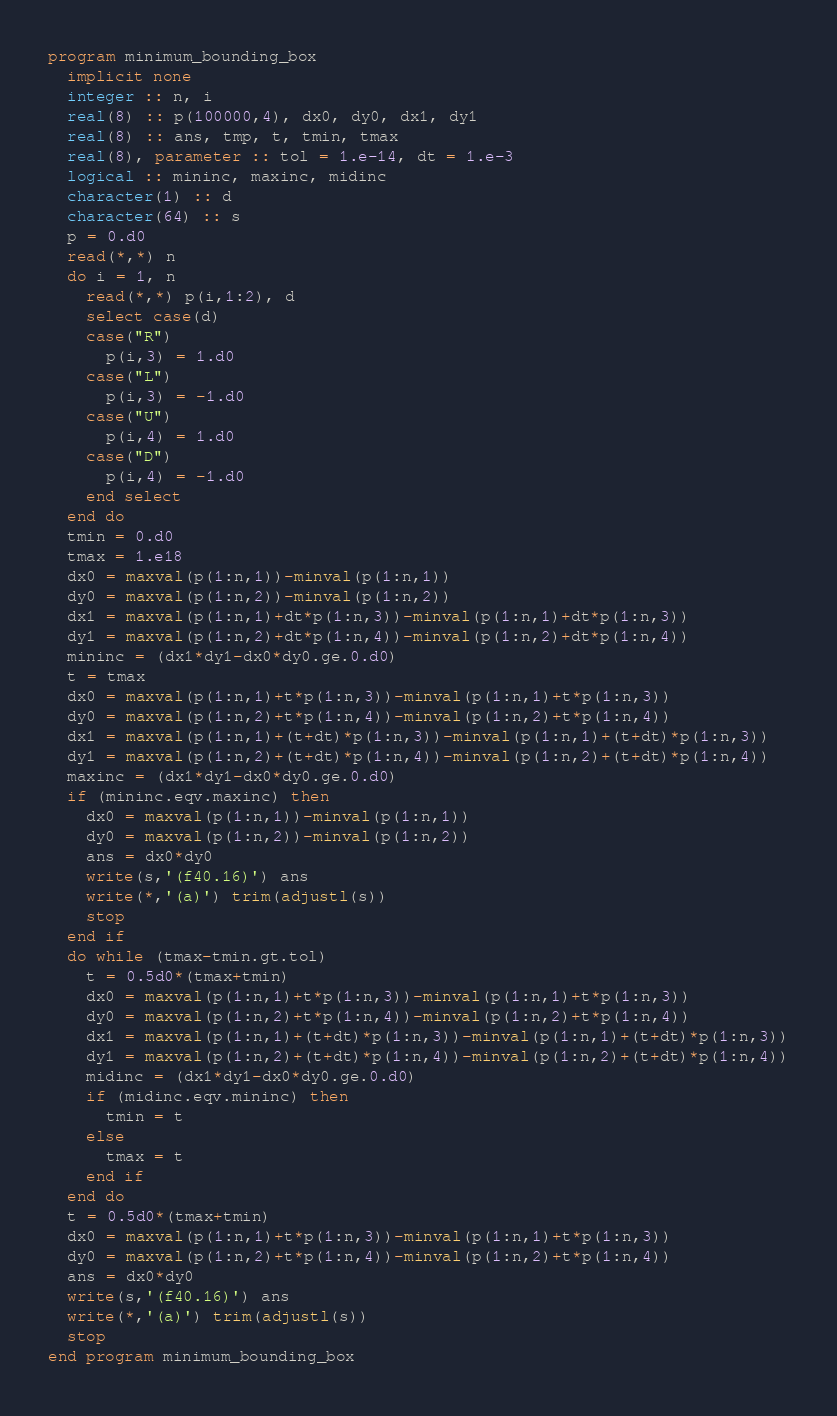<code> <loc_0><loc_0><loc_500><loc_500><_FORTRAN_>program minimum_bounding_box
  implicit none
  integer :: n, i
  real(8) :: p(100000,4), dx0, dy0, dx1, dy1
  real(8) :: ans, tmp, t, tmin, tmax
  real(8), parameter :: tol = 1.e-14, dt = 1.e-3
  logical :: mininc, maxinc, midinc
  character(1) :: d
  character(64) :: s
  p = 0.d0
  read(*,*) n
  do i = 1, n
    read(*,*) p(i,1:2), d
    select case(d)
    case("R")
      p(i,3) = 1.d0
    case("L")
      p(i,3) = -1.d0
    case("U")
      p(i,4) = 1.d0
    case("D")
      p(i,4) = -1.d0
    end select
  end do
  tmin = 0.d0
  tmax = 1.e18
  dx0 = maxval(p(1:n,1))-minval(p(1:n,1))
  dy0 = maxval(p(1:n,2))-minval(p(1:n,2))
  dx1 = maxval(p(1:n,1)+dt*p(1:n,3))-minval(p(1:n,1)+dt*p(1:n,3))
  dy1 = maxval(p(1:n,2)+dt*p(1:n,4))-minval(p(1:n,2)+dt*p(1:n,4))
  mininc = (dx1*dy1-dx0*dy0.ge.0.d0)
  t = tmax
  dx0 = maxval(p(1:n,1)+t*p(1:n,3))-minval(p(1:n,1)+t*p(1:n,3))
  dy0 = maxval(p(1:n,2)+t*p(1:n,4))-minval(p(1:n,2)+t*p(1:n,4))
  dx1 = maxval(p(1:n,1)+(t+dt)*p(1:n,3))-minval(p(1:n,1)+(t+dt)*p(1:n,3))
  dy1 = maxval(p(1:n,2)+(t+dt)*p(1:n,4))-minval(p(1:n,2)+(t+dt)*p(1:n,4))
  maxinc = (dx1*dy1-dx0*dy0.ge.0.d0)
  if (mininc.eqv.maxinc) then
    dx0 = maxval(p(1:n,1))-minval(p(1:n,1))
    dy0 = maxval(p(1:n,2))-minval(p(1:n,2))
    ans = dx0*dy0
    write(s,'(f40.16)') ans
    write(*,'(a)') trim(adjustl(s))
    stop
  end if
  do while (tmax-tmin.gt.tol)
    t = 0.5d0*(tmax+tmin)
    dx0 = maxval(p(1:n,1)+t*p(1:n,3))-minval(p(1:n,1)+t*p(1:n,3))
    dy0 = maxval(p(1:n,2)+t*p(1:n,4))-minval(p(1:n,2)+t*p(1:n,4))
    dx1 = maxval(p(1:n,1)+(t+dt)*p(1:n,3))-minval(p(1:n,1)+(t+dt)*p(1:n,3))
    dy1 = maxval(p(1:n,2)+(t+dt)*p(1:n,4))-minval(p(1:n,2)+(t+dt)*p(1:n,4))
    midinc = (dx1*dy1-dx0*dy0.ge.0.d0)
    if (midinc.eqv.mininc) then
      tmin = t
    else
      tmax = t
    end if
  end do
  t = 0.5d0*(tmax+tmin)
  dx0 = maxval(p(1:n,1)+t*p(1:n,3))-minval(p(1:n,1)+t*p(1:n,3))
  dy0 = maxval(p(1:n,2)+t*p(1:n,4))-minval(p(1:n,2)+t*p(1:n,4))
  ans = dx0*dy0
  write(s,'(f40.16)') ans
  write(*,'(a)') trim(adjustl(s))
  stop
end program minimum_bounding_box</code> 